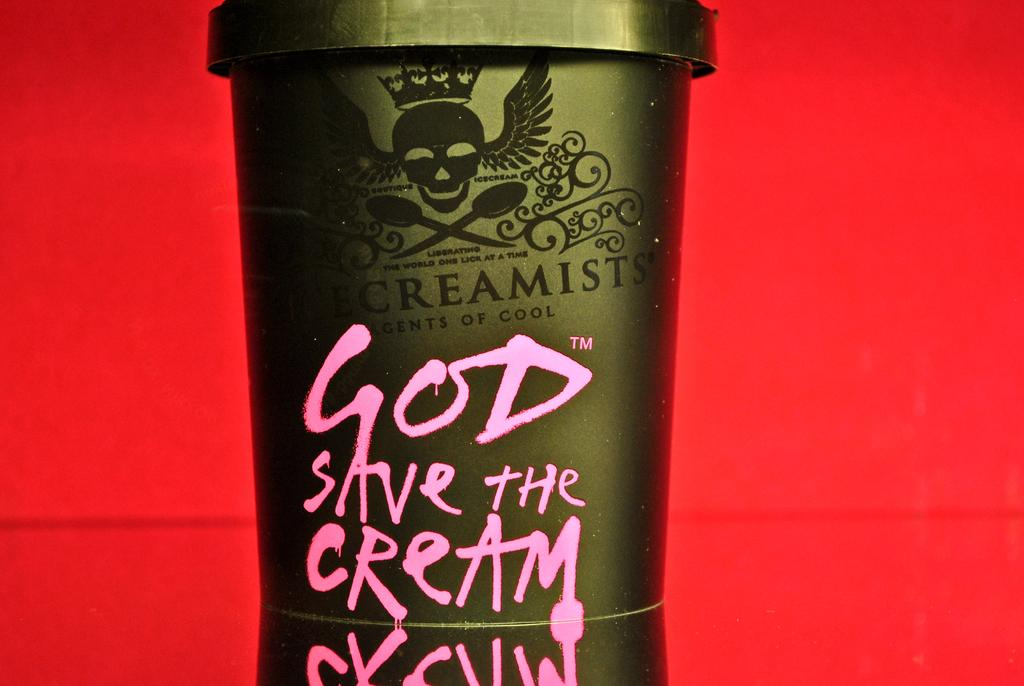<image>
Offer a succinct explanation of the picture presented. Cup that says Creamests Agents of Cool, and says God Save The Cream. 